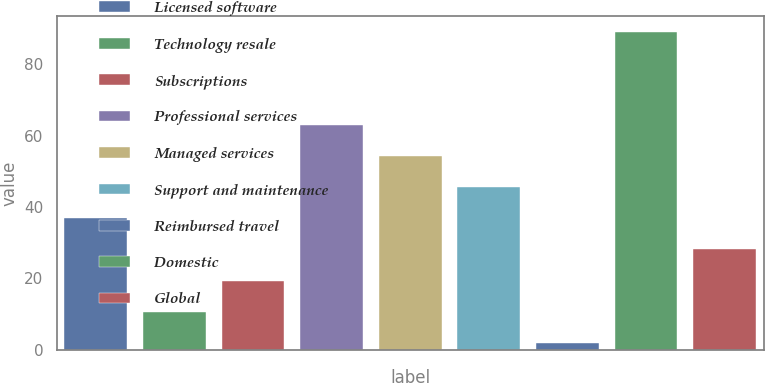Convert chart. <chart><loc_0><loc_0><loc_500><loc_500><bar_chart><fcel>Licensed software<fcel>Technology resale<fcel>Subscriptions<fcel>Professional services<fcel>Managed services<fcel>Support and maintenance<fcel>Reimbursed travel<fcel>Domestic<fcel>Global<nl><fcel>36.8<fcel>10.7<fcel>19.4<fcel>62.9<fcel>54.2<fcel>45.5<fcel>2<fcel>89<fcel>28.1<nl></chart> 